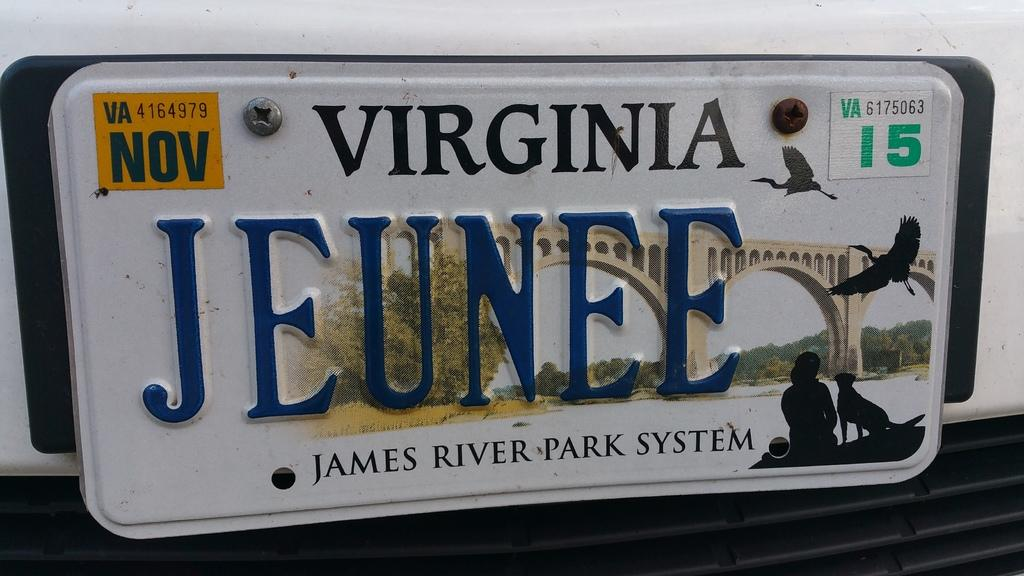<image>
Present a compact description of the photo's key features. the state of Virginia is represented on a license plate 